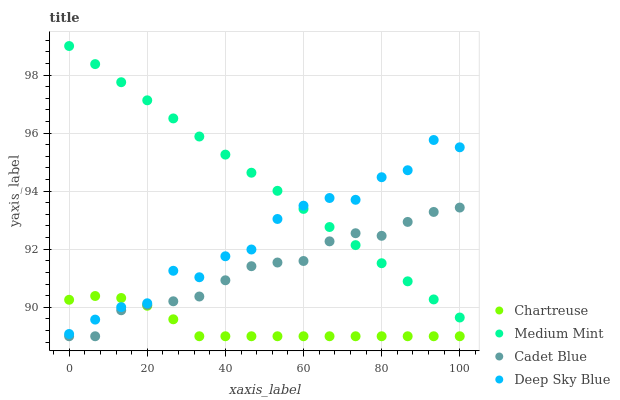Does Chartreuse have the minimum area under the curve?
Answer yes or no. Yes. Does Medium Mint have the maximum area under the curve?
Answer yes or no. Yes. Does Cadet Blue have the minimum area under the curve?
Answer yes or no. No. Does Cadet Blue have the maximum area under the curve?
Answer yes or no. No. Is Medium Mint the smoothest?
Answer yes or no. Yes. Is Deep Sky Blue the roughest?
Answer yes or no. Yes. Is Chartreuse the smoothest?
Answer yes or no. No. Is Chartreuse the roughest?
Answer yes or no. No. Does Chartreuse have the lowest value?
Answer yes or no. Yes. Does Deep Sky Blue have the lowest value?
Answer yes or no. No. Does Medium Mint have the highest value?
Answer yes or no. Yes. Does Cadet Blue have the highest value?
Answer yes or no. No. Is Cadet Blue less than Deep Sky Blue?
Answer yes or no. Yes. Is Medium Mint greater than Chartreuse?
Answer yes or no. Yes. Does Deep Sky Blue intersect Chartreuse?
Answer yes or no. Yes. Is Deep Sky Blue less than Chartreuse?
Answer yes or no. No. Is Deep Sky Blue greater than Chartreuse?
Answer yes or no. No. Does Cadet Blue intersect Deep Sky Blue?
Answer yes or no. No. 